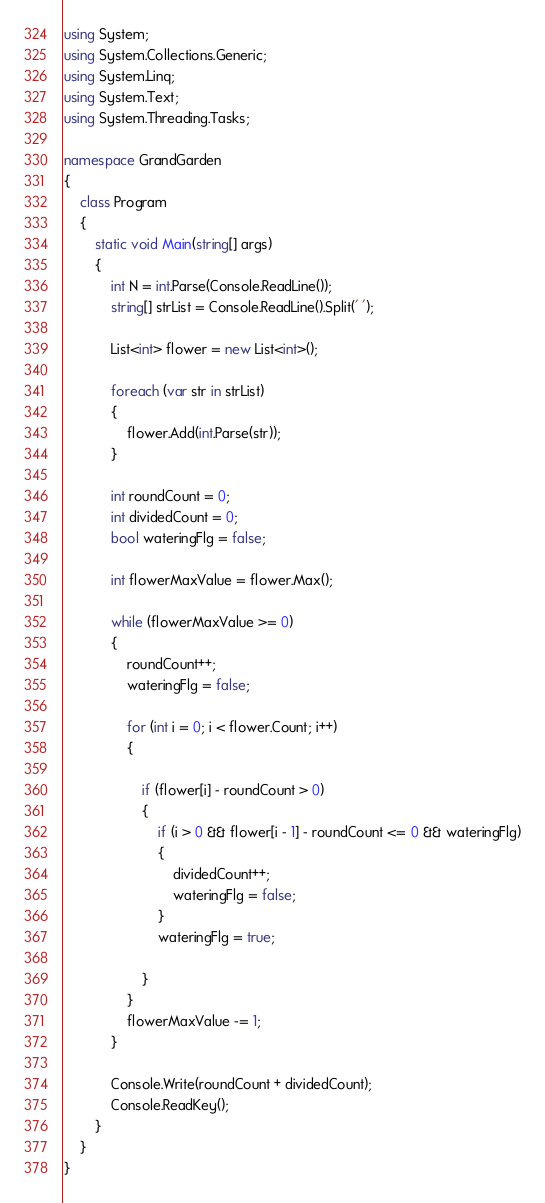<code> <loc_0><loc_0><loc_500><loc_500><_C#_>using System;
using System.Collections.Generic;
using System.Linq;
using System.Text;
using System.Threading.Tasks;

namespace GrandGarden
{
    class Program
    {
        static void Main(string[] args)
        {
            int N = int.Parse(Console.ReadLine());
            string[] strList = Console.ReadLine().Split(' ');

            List<int> flower = new List<int>();

            foreach (var str in strList)
            {
                flower.Add(int.Parse(str));
            }

            int roundCount = 0;
            int dividedCount = 0;
            bool wateringFlg = false;

            int flowerMaxValue = flower.Max();

            while (flowerMaxValue >= 0)
            {
                roundCount++;
                wateringFlg = false;

                for (int i = 0; i < flower.Count; i++)
                {

                    if (flower[i] - roundCount > 0)
                    {
                        if (i > 0 && flower[i - 1] - roundCount <= 0 && wateringFlg)
                        {
                            dividedCount++;
                            wateringFlg = false;
                        }
                        wateringFlg = true;

                    }
                }
                flowerMaxValue -= 1;
            }

            Console.Write(roundCount + dividedCount);
            Console.ReadKey();
        }
    }
}
</code> 